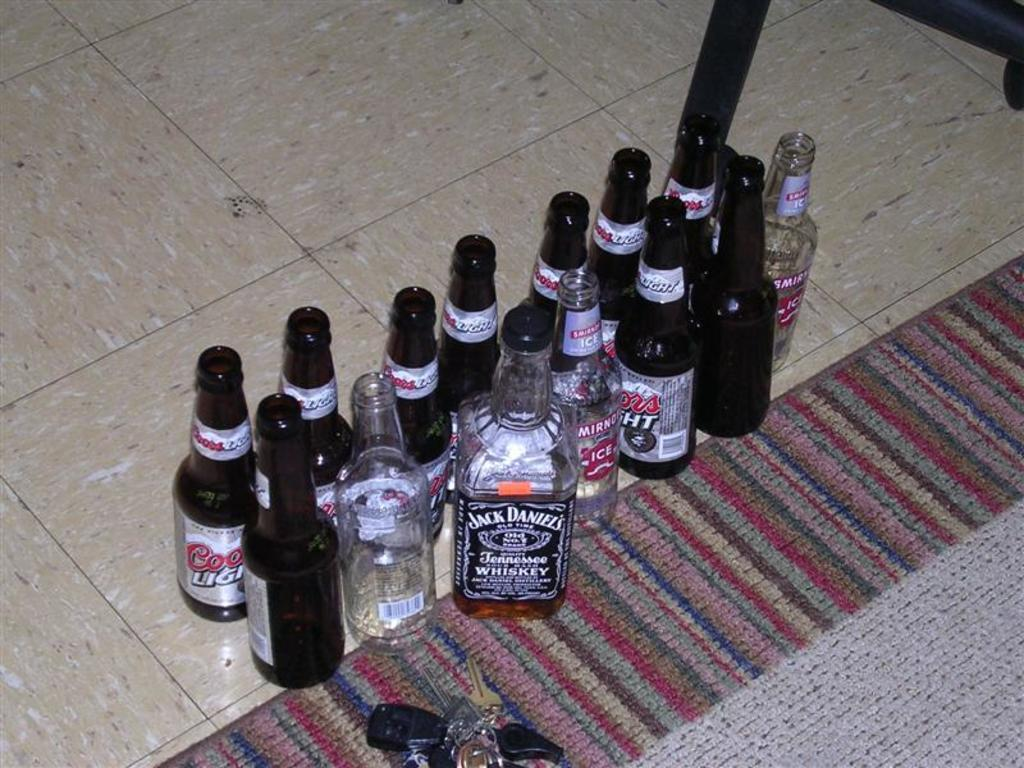<image>
Present a compact description of the photo's key features. A half-full Jack Daniels bottle stands tall amongst some Coors Light bottles, Smirnoff Ice bottles, and car keys. 